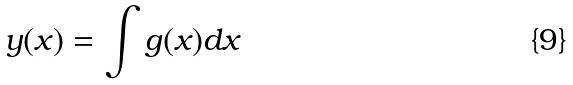Convert formula to latex. <formula><loc_0><loc_0><loc_500><loc_500>y ( x ) = \int g ( x ) d x</formula> 